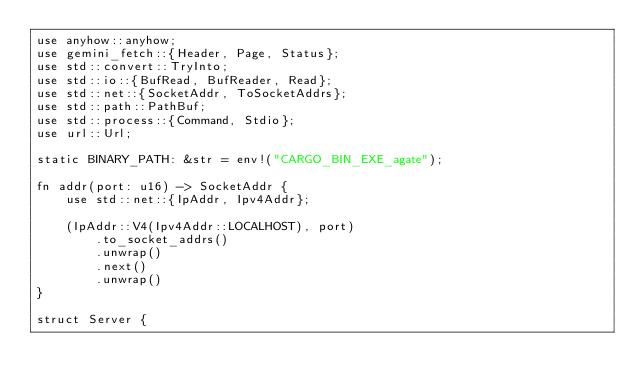<code> <loc_0><loc_0><loc_500><loc_500><_Rust_>use anyhow::anyhow;
use gemini_fetch::{Header, Page, Status};
use std::convert::TryInto;
use std::io::{BufRead, BufReader, Read};
use std::net::{SocketAddr, ToSocketAddrs};
use std::path::PathBuf;
use std::process::{Command, Stdio};
use url::Url;

static BINARY_PATH: &str = env!("CARGO_BIN_EXE_agate");

fn addr(port: u16) -> SocketAddr {
    use std::net::{IpAddr, Ipv4Addr};

    (IpAddr::V4(Ipv4Addr::LOCALHOST), port)
        .to_socket_addrs()
        .unwrap()
        .next()
        .unwrap()
}

struct Server {</code> 